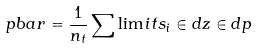Convert formula to latex. <formula><loc_0><loc_0><loc_500><loc_500>\ p b a r = \frac { 1 } { n _ { t } } \sum \lim i t s _ { i } \in d z \in d p</formula> 